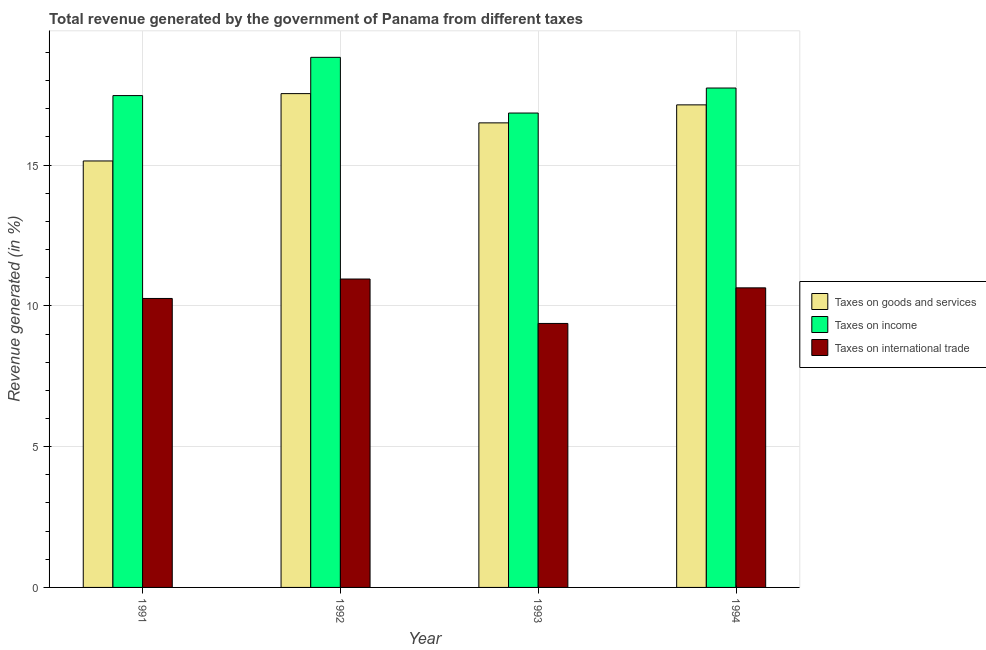How many different coloured bars are there?
Keep it short and to the point. 3. Are the number of bars per tick equal to the number of legend labels?
Offer a terse response. Yes. How many bars are there on the 1st tick from the left?
Provide a succinct answer. 3. How many bars are there on the 2nd tick from the right?
Your response must be concise. 3. In how many cases, is the number of bars for a given year not equal to the number of legend labels?
Give a very brief answer. 0. What is the percentage of revenue generated by taxes on goods and services in 1991?
Your answer should be very brief. 15.15. Across all years, what is the maximum percentage of revenue generated by tax on international trade?
Keep it short and to the point. 10.95. Across all years, what is the minimum percentage of revenue generated by taxes on income?
Make the answer very short. 16.85. What is the total percentage of revenue generated by taxes on income in the graph?
Keep it short and to the point. 70.88. What is the difference between the percentage of revenue generated by taxes on income in 1991 and that in 1993?
Give a very brief answer. 0.62. What is the difference between the percentage of revenue generated by tax on international trade in 1993 and the percentage of revenue generated by taxes on income in 1994?
Offer a terse response. -1.26. What is the average percentage of revenue generated by taxes on income per year?
Make the answer very short. 17.72. In the year 1992, what is the difference between the percentage of revenue generated by taxes on goods and services and percentage of revenue generated by taxes on income?
Make the answer very short. 0. In how many years, is the percentage of revenue generated by taxes on income greater than 18 %?
Provide a short and direct response. 1. What is the ratio of the percentage of revenue generated by tax on international trade in 1992 to that in 1993?
Offer a terse response. 1.17. Is the percentage of revenue generated by taxes on goods and services in 1991 less than that in 1992?
Give a very brief answer. Yes. Is the difference between the percentage of revenue generated by taxes on income in 1991 and 1993 greater than the difference between the percentage of revenue generated by taxes on goods and services in 1991 and 1993?
Give a very brief answer. No. What is the difference between the highest and the second highest percentage of revenue generated by taxes on income?
Your answer should be compact. 1.09. What is the difference between the highest and the lowest percentage of revenue generated by taxes on income?
Provide a short and direct response. 1.98. What does the 3rd bar from the left in 1994 represents?
Make the answer very short. Taxes on international trade. What does the 2nd bar from the right in 1993 represents?
Offer a terse response. Taxes on income. Is it the case that in every year, the sum of the percentage of revenue generated by taxes on goods and services and percentage of revenue generated by taxes on income is greater than the percentage of revenue generated by tax on international trade?
Provide a short and direct response. Yes. How many bars are there?
Keep it short and to the point. 12. Are all the bars in the graph horizontal?
Offer a very short reply. No. How many years are there in the graph?
Give a very brief answer. 4. Does the graph contain any zero values?
Make the answer very short. No. How many legend labels are there?
Keep it short and to the point. 3. What is the title of the graph?
Keep it short and to the point. Total revenue generated by the government of Panama from different taxes. Does "Agricultural Nitrous Oxide" appear as one of the legend labels in the graph?
Your answer should be very brief. No. What is the label or title of the Y-axis?
Your response must be concise. Revenue generated (in %). What is the Revenue generated (in %) in Taxes on goods and services in 1991?
Provide a short and direct response. 15.15. What is the Revenue generated (in %) in Taxes on income in 1991?
Provide a short and direct response. 17.47. What is the Revenue generated (in %) in Taxes on international trade in 1991?
Provide a short and direct response. 10.26. What is the Revenue generated (in %) in Taxes on goods and services in 1992?
Ensure brevity in your answer.  17.54. What is the Revenue generated (in %) of Taxes on income in 1992?
Your answer should be compact. 18.83. What is the Revenue generated (in %) of Taxes on international trade in 1992?
Offer a terse response. 10.95. What is the Revenue generated (in %) of Taxes on goods and services in 1993?
Provide a short and direct response. 16.5. What is the Revenue generated (in %) of Taxes on income in 1993?
Ensure brevity in your answer.  16.85. What is the Revenue generated (in %) in Taxes on international trade in 1993?
Keep it short and to the point. 9.38. What is the Revenue generated (in %) in Taxes on goods and services in 1994?
Keep it short and to the point. 17.14. What is the Revenue generated (in %) in Taxes on income in 1994?
Your answer should be compact. 17.74. What is the Revenue generated (in %) of Taxes on international trade in 1994?
Ensure brevity in your answer.  10.64. Across all years, what is the maximum Revenue generated (in %) of Taxes on goods and services?
Your response must be concise. 17.54. Across all years, what is the maximum Revenue generated (in %) in Taxes on income?
Your answer should be compact. 18.83. Across all years, what is the maximum Revenue generated (in %) in Taxes on international trade?
Provide a short and direct response. 10.95. Across all years, what is the minimum Revenue generated (in %) in Taxes on goods and services?
Provide a succinct answer. 15.15. Across all years, what is the minimum Revenue generated (in %) of Taxes on income?
Your answer should be very brief. 16.85. Across all years, what is the minimum Revenue generated (in %) of Taxes on international trade?
Give a very brief answer. 9.38. What is the total Revenue generated (in %) of Taxes on goods and services in the graph?
Keep it short and to the point. 66.32. What is the total Revenue generated (in %) in Taxes on income in the graph?
Provide a short and direct response. 70.88. What is the total Revenue generated (in %) of Taxes on international trade in the graph?
Your answer should be very brief. 41.23. What is the difference between the Revenue generated (in %) of Taxes on goods and services in 1991 and that in 1992?
Offer a terse response. -2.39. What is the difference between the Revenue generated (in %) in Taxes on income in 1991 and that in 1992?
Ensure brevity in your answer.  -1.36. What is the difference between the Revenue generated (in %) in Taxes on international trade in 1991 and that in 1992?
Your response must be concise. -0.69. What is the difference between the Revenue generated (in %) of Taxes on goods and services in 1991 and that in 1993?
Provide a succinct answer. -1.35. What is the difference between the Revenue generated (in %) in Taxes on income in 1991 and that in 1993?
Make the answer very short. 0.62. What is the difference between the Revenue generated (in %) in Taxes on international trade in 1991 and that in 1993?
Ensure brevity in your answer.  0.89. What is the difference between the Revenue generated (in %) in Taxes on goods and services in 1991 and that in 1994?
Offer a very short reply. -1.99. What is the difference between the Revenue generated (in %) in Taxes on income in 1991 and that in 1994?
Keep it short and to the point. -0.27. What is the difference between the Revenue generated (in %) in Taxes on international trade in 1991 and that in 1994?
Provide a succinct answer. -0.38. What is the difference between the Revenue generated (in %) of Taxes on goods and services in 1992 and that in 1993?
Keep it short and to the point. 1.04. What is the difference between the Revenue generated (in %) in Taxes on income in 1992 and that in 1993?
Provide a short and direct response. 1.98. What is the difference between the Revenue generated (in %) in Taxes on international trade in 1992 and that in 1993?
Offer a very short reply. 1.58. What is the difference between the Revenue generated (in %) in Taxes on goods and services in 1992 and that in 1994?
Your response must be concise. 0.4. What is the difference between the Revenue generated (in %) in Taxes on income in 1992 and that in 1994?
Make the answer very short. 1.09. What is the difference between the Revenue generated (in %) in Taxes on international trade in 1992 and that in 1994?
Make the answer very short. 0.31. What is the difference between the Revenue generated (in %) of Taxes on goods and services in 1993 and that in 1994?
Your answer should be very brief. -0.64. What is the difference between the Revenue generated (in %) in Taxes on income in 1993 and that in 1994?
Keep it short and to the point. -0.89. What is the difference between the Revenue generated (in %) of Taxes on international trade in 1993 and that in 1994?
Offer a very short reply. -1.26. What is the difference between the Revenue generated (in %) of Taxes on goods and services in 1991 and the Revenue generated (in %) of Taxes on income in 1992?
Your response must be concise. -3.68. What is the difference between the Revenue generated (in %) in Taxes on goods and services in 1991 and the Revenue generated (in %) in Taxes on international trade in 1992?
Your answer should be very brief. 4.19. What is the difference between the Revenue generated (in %) in Taxes on income in 1991 and the Revenue generated (in %) in Taxes on international trade in 1992?
Offer a terse response. 6.51. What is the difference between the Revenue generated (in %) in Taxes on goods and services in 1991 and the Revenue generated (in %) in Taxes on income in 1993?
Make the answer very short. -1.7. What is the difference between the Revenue generated (in %) of Taxes on goods and services in 1991 and the Revenue generated (in %) of Taxes on international trade in 1993?
Provide a succinct answer. 5.77. What is the difference between the Revenue generated (in %) in Taxes on income in 1991 and the Revenue generated (in %) in Taxes on international trade in 1993?
Your response must be concise. 8.09. What is the difference between the Revenue generated (in %) of Taxes on goods and services in 1991 and the Revenue generated (in %) of Taxes on income in 1994?
Provide a succinct answer. -2.59. What is the difference between the Revenue generated (in %) in Taxes on goods and services in 1991 and the Revenue generated (in %) in Taxes on international trade in 1994?
Your response must be concise. 4.51. What is the difference between the Revenue generated (in %) in Taxes on income in 1991 and the Revenue generated (in %) in Taxes on international trade in 1994?
Provide a short and direct response. 6.83. What is the difference between the Revenue generated (in %) in Taxes on goods and services in 1992 and the Revenue generated (in %) in Taxes on income in 1993?
Your answer should be very brief. 0.69. What is the difference between the Revenue generated (in %) in Taxes on goods and services in 1992 and the Revenue generated (in %) in Taxes on international trade in 1993?
Offer a very short reply. 8.16. What is the difference between the Revenue generated (in %) of Taxes on income in 1992 and the Revenue generated (in %) of Taxes on international trade in 1993?
Make the answer very short. 9.45. What is the difference between the Revenue generated (in %) in Taxes on goods and services in 1992 and the Revenue generated (in %) in Taxes on income in 1994?
Your answer should be compact. -0.2. What is the difference between the Revenue generated (in %) of Taxes on goods and services in 1992 and the Revenue generated (in %) of Taxes on international trade in 1994?
Give a very brief answer. 6.9. What is the difference between the Revenue generated (in %) in Taxes on income in 1992 and the Revenue generated (in %) in Taxes on international trade in 1994?
Provide a succinct answer. 8.19. What is the difference between the Revenue generated (in %) of Taxes on goods and services in 1993 and the Revenue generated (in %) of Taxes on income in 1994?
Keep it short and to the point. -1.24. What is the difference between the Revenue generated (in %) of Taxes on goods and services in 1993 and the Revenue generated (in %) of Taxes on international trade in 1994?
Offer a very short reply. 5.86. What is the difference between the Revenue generated (in %) of Taxes on income in 1993 and the Revenue generated (in %) of Taxes on international trade in 1994?
Keep it short and to the point. 6.21. What is the average Revenue generated (in %) of Taxes on goods and services per year?
Provide a short and direct response. 16.58. What is the average Revenue generated (in %) of Taxes on income per year?
Provide a succinct answer. 17.72. What is the average Revenue generated (in %) in Taxes on international trade per year?
Your answer should be compact. 10.31. In the year 1991, what is the difference between the Revenue generated (in %) of Taxes on goods and services and Revenue generated (in %) of Taxes on income?
Provide a short and direct response. -2.32. In the year 1991, what is the difference between the Revenue generated (in %) in Taxes on goods and services and Revenue generated (in %) in Taxes on international trade?
Keep it short and to the point. 4.88. In the year 1991, what is the difference between the Revenue generated (in %) in Taxes on income and Revenue generated (in %) in Taxes on international trade?
Provide a succinct answer. 7.21. In the year 1992, what is the difference between the Revenue generated (in %) of Taxes on goods and services and Revenue generated (in %) of Taxes on income?
Offer a very short reply. -1.29. In the year 1992, what is the difference between the Revenue generated (in %) in Taxes on goods and services and Revenue generated (in %) in Taxes on international trade?
Your answer should be very brief. 6.58. In the year 1992, what is the difference between the Revenue generated (in %) of Taxes on income and Revenue generated (in %) of Taxes on international trade?
Give a very brief answer. 7.87. In the year 1993, what is the difference between the Revenue generated (in %) in Taxes on goods and services and Revenue generated (in %) in Taxes on income?
Provide a succinct answer. -0.35. In the year 1993, what is the difference between the Revenue generated (in %) of Taxes on goods and services and Revenue generated (in %) of Taxes on international trade?
Offer a terse response. 7.12. In the year 1993, what is the difference between the Revenue generated (in %) in Taxes on income and Revenue generated (in %) in Taxes on international trade?
Your response must be concise. 7.47. In the year 1994, what is the difference between the Revenue generated (in %) of Taxes on goods and services and Revenue generated (in %) of Taxes on income?
Provide a succinct answer. -0.6. In the year 1994, what is the difference between the Revenue generated (in %) in Taxes on goods and services and Revenue generated (in %) in Taxes on international trade?
Ensure brevity in your answer.  6.5. In the year 1994, what is the difference between the Revenue generated (in %) of Taxes on income and Revenue generated (in %) of Taxes on international trade?
Ensure brevity in your answer.  7.1. What is the ratio of the Revenue generated (in %) of Taxes on goods and services in 1991 to that in 1992?
Provide a succinct answer. 0.86. What is the ratio of the Revenue generated (in %) of Taxes on income in 1991 to that in 1992?
Ensure brevity in your answer.  0.93. What is the ratio of the Revenue generated (in %) of Taxes on international trade in 1991 to that in 1992?
Provide a short and direct response. 0.94. What is the ratio of the Revenue generated (in %) in Taxes on goods and services in 1991 to that in 1993?
Offer a very short reply. 0.92. What is the ratio of the Revenue generated (in %) of Taxes on income in 1991 to that in 1993?
Your response must be concise. 1.04. What is the ratio of the Revenue generated (in %) in Taxes on international trade in 1991 to that in 1993?
Your answer should be very brief. 1.09. What is the ratio of the Revenue generated (in %) in Taxes on goods and services in 1991 to that in 1994?
Your response must be concise. 0.88. What is the ratio of the Revenue generated (in %) of Taxes on income in 1991 to that in 1994?
Your answer should be very brief. 0.98. What is the ratio of the Revenue generated (in %) in Taxes on international trade in 1991 to that in 1994?
Provide a short and direct response. 0.96. What is the ratio of the Revenue generated (in %) of Taxes on goods and services in 1992 to that in 1993?
Give a very brief answer. 1.06. What is the ratio of the Revenue generated (in %) in Taxes on income in 1992 to that in 1993?
Ensure brevity in your answer.  1.12. What is the ratio of the Revenue generated (in %) of Taxes on international trade in 1992 to that in 1993?
Your answer should be very brief. 1.17. What is the ratio of the Revenue generated (in %) of Taxes on goods and services in 1992 to that in 1994?
Your answer should be compact. 1.02. What is the ratio of the Revenue generated (in %) in Taxes on income in 1992 to that in 1994?
Provide a short and direct response. 1.06. What is the ratio of the Revenue generated (in %) of Taxes on international trade in 1992 to that in 1994?
Your response must be concise. 1.03. What is the ratio of the Revenue generated (in %) in Taxes on goods and services in 1993 to that in 1994?
Provide a short and direct response. 0.96. What is the ratio of the Revenue generated (in %) in Taxes on income in 1993 to that in 1994?
Your answer should be very brief. 0.95. What is the ratio of the Revenue generated (in %) in Taxes on international trade in 1993 to that in 1994?
Ensure brevity in your answer.  0.88. What is the difference between the highest and the second highest Revenue generated (in %) of Taxes on goods and services?
Your answer should be compact. 0.4. What is the difference between the highest and the second highest Revenue generated (in %) of Taxes on income?
Offer a very short reply. 1.09. What is the difference between the highest and the second highest Revenue generated (in %) of Taxes on international trade?
Your answer should be very brief. 0.31. What is the difference between the highest and the lowest Revenue generated (in %) in Taxes on goods and services?
Provide a succinct answer. 2.39. What is the difference between the highest and the lowest Revenue generated (in %) in Taxes on income?
Offer a terse response. 1.98. What is the difference between the highest and the lowest Revenue generated (in %) in Taxes on international trade?
Provide a short and direct response. 1.58. 